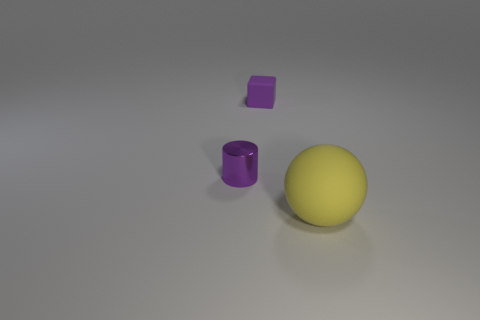Can you describe the colors in the image? Certainly! The image features objects with distinct colors: a yellow sphere, a metallic cylinder that appears to have a greyish hue owing to its material, and a purple cube. 